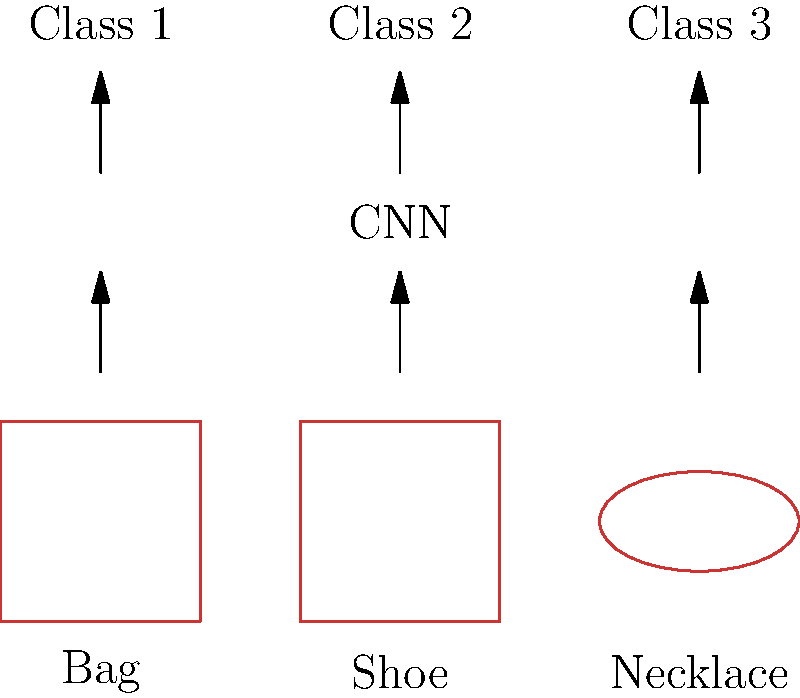In the image recognition task for identifying fashion accessories from hand-drawn sketches, what is the primary advantage of using a Convolutional Neural Network (CNN) over a traditional Multi-Layer Perceptron (MLP) for feature extraction? To understand the advantage of CNNs over MLPs in this context, let's break down the problem and solution:

1. Nature of the input: Hand-drawn sketches of fashion accessories are 2D images with spatial relationships between pixels.

2. MLP limitations:
   a. MLPs treat input as a flattened 1D vector, losing spatial information.
   b. They don't account for the hierarchical nature of visual features.
   c. MLPs are not translation-invariant, meaning they struggle with slight variations in input positioning.

3. CNN advantages:
   a. Convolutional layers preserve spatial relationships in the input.
   b. They use shared weights and local receptive fields, reducing the number of parameters.
   c. Pooling layers provide translation invariance, allowing the network to recognize features regardless of their exact position.

4. Feature extraction:
   a. CNNs automatically learn hierarchical features, from simple edges to complex shapes.
   b. This hierarchical learning is particularly suited for sketch recognition, as it can capture the essence of accessories at different levels of abstraction.

5. Performance on sketch data:
   a. CNNs can better handle the variability in hand-drawn sketches, including different styles and levels of detail.
   b. They can focus on key features that define each accessory type, ignoring irrelevant variations.

In summary, the primary advantage of CNNs is their ability to preserve and leverage spatial information in the input, which is crucial for accurate recognition of hand-drawn fashion accessory sketches.
Answer: Spatial information preservation 